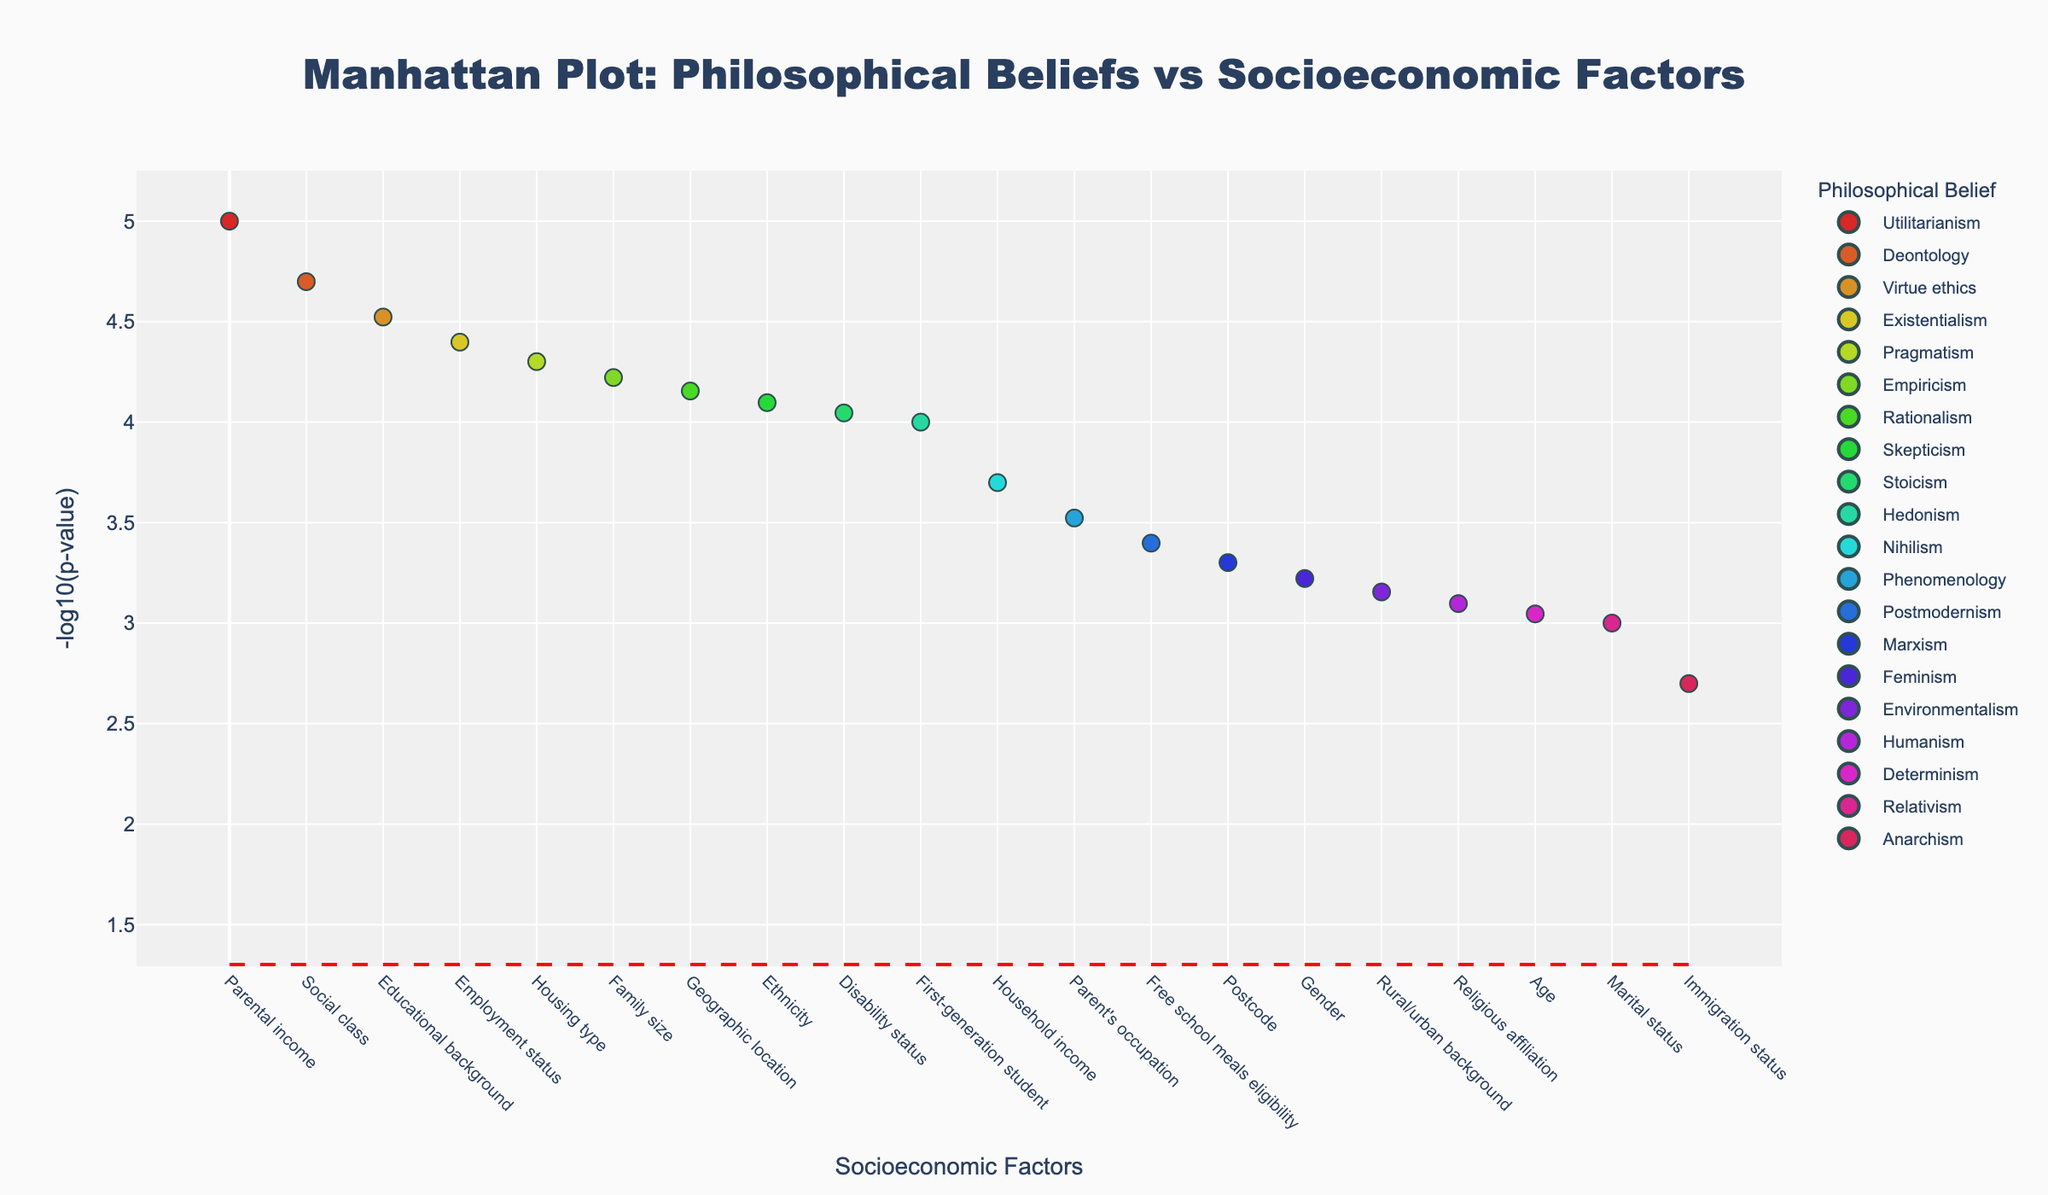What is the title of the figure? The title of the figure is shown at the top and usually provides an overview of what the plot represents. Here, the title is: "Manhattan Plot: Philosophical Beliefs vs Socioeconomic Factors".
Answer: Manhattan Plot: Philosophical Beliefs vs Socioeconomic Factors What are the axes titles? The x-axis and y-axis titles provide information on what is being measured on each axis. Here, the x-axis title is "Socioeconomic Factors", and the y-axis title is "-log10(p-value)".
Answer: Socioeconomic Factors, -log10(p-value) Which philosophical belief has the lowest p-value? The lowest p-value corresponds to the highest point on the y-axis (since y-axis is -log10(p-value)). The highest point is for "Utilitarianism" at the University of Bath.
Answer: Utilitarianism How many philosophical beliefs are shown in the figure? The legend indicates the number of unique categories plotted. Here, the legend lists 20 unique philosophical beliefs.
Answer: 20 Which socioeconomic factor has the highest -log10(p-value) and what is the corresponding university? To find this, look for the highest point on the y-axis. The corresponding label indicates "Parental income" at University of Bath.
Answer: Parental income, University of Bath Is there any socioeconomic factor related to 'Gender'? To answer this, identify the specific socioeconomic factor labeled as "Gender". The data point is related to "Feminism" at the University of Glasgow.
Answer: Yes, University of Glasgow What is the significance threshold line and which points are above it? The significance threshold line is shown as a dashed line (in red) on the plot. Points above this line indicate significant correlations. Points such as those for Utilitarianism, Deontology, and others are above this line.
Answer: Red dashed line, Utilitarianism, Deontology, etc Which university is associated with Marxism and what is the socioeconomic factor? To find this, identify the point related to "Marxism" and follow the corresponding labels. It is related to the University of Birmingham and the socioeconomic factor is "Postcode".
Answer: University of Birmingham, Postcode Compare the -log10(p-value) for Empiricism and Stoicism. Which is higher? Find the points labeled Empiricism and Stoicism and compare their y-axis positions. Empiricism (University of Manchester) has a higher -log10(p-value) than Stoicism (University of Warwick).
Answer: Empiricism 